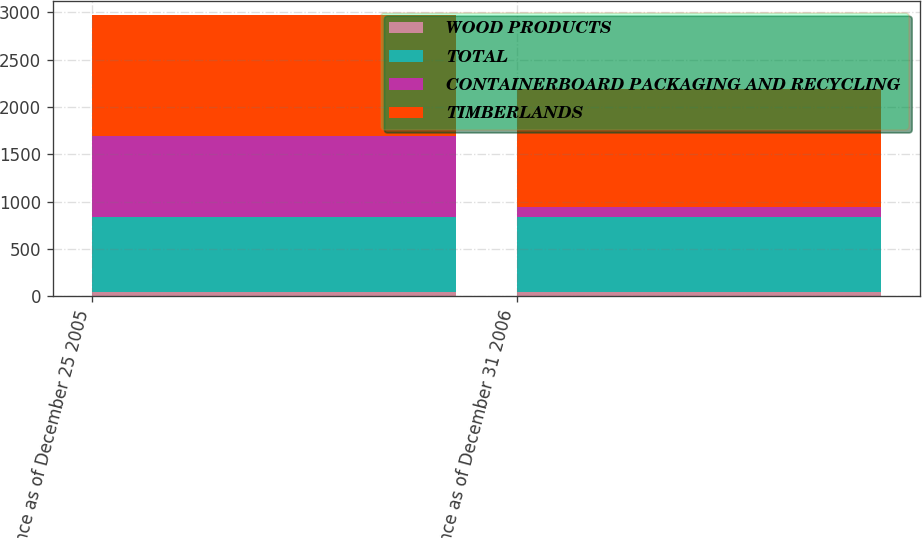Convert chart to OTSL. <chart><loc_0><loc_0><loc_500><loc_500><stacked_bar_chart><ecel><fcel>Balance as of December 25 2005<fcel>Balance as of December 31 2006<nl><fcel>WOOD PRODUCTS<fcel>40<fcel>40<nl><fcel>TOTAL<fcel>798<fcel>800<nl><fcel>CONTAINERBOARD PACKAGING AND RECYCLING<fcel>857<fcel>105<nl><fcel>TIMBERLANDS<fcel>1275<fcel>1244<nl></chart> 